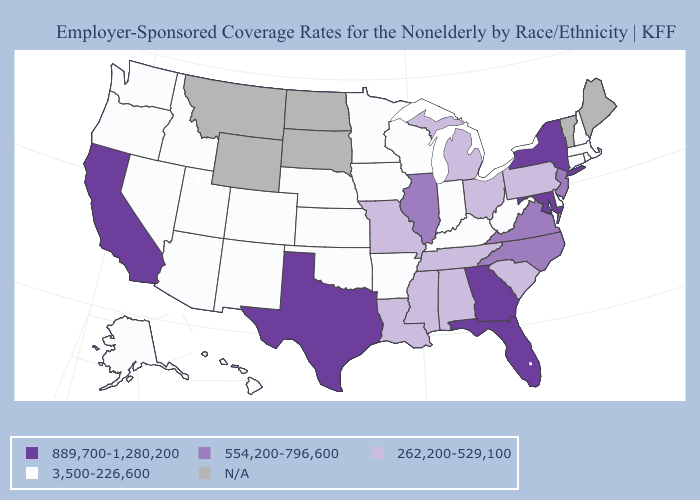Name the states that have a value in the range 3,500-226,600?
Quick response, please. Alaska, Arizona, Arkansas, Colorado, Connecticut, Delaware, Hawaii, Idaho, Indiana, Iowa, Kansas, Kentucky, Massachusetts, Minnesota, Nebraska, Nevada, New Hampshire, New Mexico, Oklahoma, Oregon, Rhode Island, Utah, Washington, West Virginia, Wisconsin. Does New Hampshire have the highest value in the Northeast?
Be succinct. No. What is the value of Texas?
Concise answer only. 889,700-1,280,200. What is the highest value in the USA?
Concise answer only. 889,700-1,280,200. Name the states that have a value in the range 554,200-796,600?
Concise answer only. Illinois, New Jersey, North Carolina, Virginia. Does Florida have the highest value in the USA?
Answer briefly. Yes. Does the map have missing data?
Write a very short answer. Yes. What is the value of Tennessee?
Give a very brief answer. 262,200-529,100. What is the highest value in states that border Kansas?
Give a very brief answer. 262,200-529,100. What is the value of West Virginia?
Short answer required. 3,500-226,600. How many symbols are there in the legend?
Concise answer only. 5. What is the value of Michigan?
Concise answer only. 262,200-529,100. Which states hav the highest value in the MidWest?
Answer briefly. Illinois. Does West Virginia have the lowest value in the USA?
Concise answer only. Yes. 